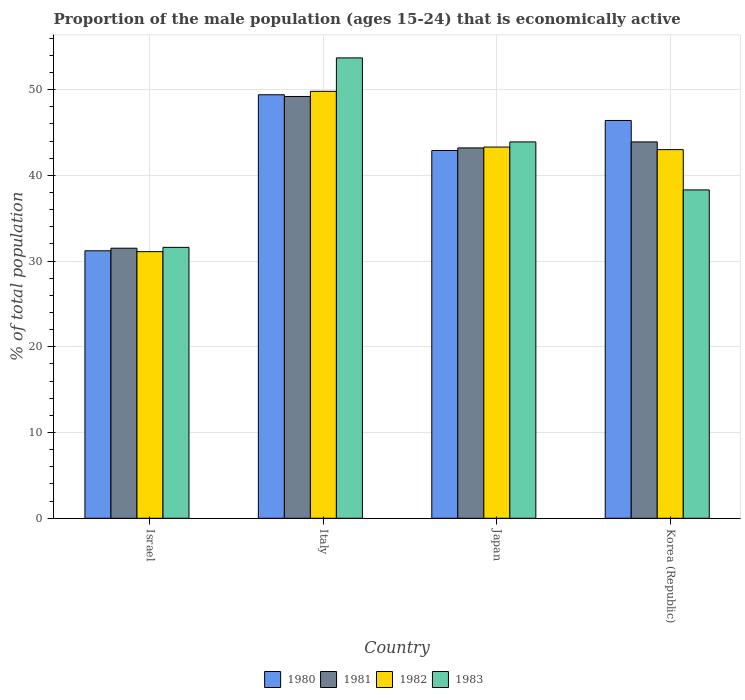How many different coloured bars are there?
Your response must be concise. 4. How many bars are there on the 1st tick from the left?
Your response must be concise. 4. What is the proportion of the male population that is economically active in 1980 in Korea (Republic)?
Make the answer very short. 46.4. Across all countries, what is the maximum proportion of the male population that is economically active in 1983?
Your response must be concise. 53.7. Across all countries, what is the minimum proportion of the male population that is economically active in 1983?
Offer a very short reply. 31.6. In which country was the proportion of the male population that is economically active in 1980 maximum?
Make the answer very short. Italy. What is the total proportion of the male population that is economically active in 1983 in the graph?
Offer a very short reply. 167.5. What is the difference between the proportion of the male population that is economically active in 1980 in Italy and that in Japan?
Provide a short and direct response. 6.5. What is the difference between the proportion of the male population that is economically active in 1981 in Japan and the proportion of the male population that is economically active in 1982 in Italy?
Provide a succinct answer. -6.6. What is the average proportion of the male population that is economically active in 1980 per country?
Your answer should be compact. 42.48. What is the difference between the proportion of the male population that is economically active of/in 1980 and proportion of the male population that is economically active of/in 1982 in Israel?
Make the answer very short. 0.1. What is the ratio of the proportion of the male population that is economically active in 1982 in Italy to that in Korea (Republic)?
Your response must be concise. 1.16. What is the difference between the highest and the second highest proportion of the male population that is economically active in 1980?
Keep it short and to the point. 6.5. What is the difference between the highest and the lowest proportion of the male population that is economically active in 1983?
Offer a very short reply. 22.1. In how many countries, is the proportion of the male population that is economically active in 1983 greater than the average proportion of the male population that is economically active in 1983 taken over all countries?
Offer a terse response. 2. Is it the case that in every country, the sum of the proportion of the male population that is economically active in 1980 and proportion of the male population that is economically active in 1982 is greater than the sum of proportion of the male population that is economically active in 1981 and proportion of the male population that is economically active in 1983?
Make the answer very short. No. Is it the case that in every country, the sum of the proportion of the male population that is economically active in 1980 and proportion of the male population that is economically active in 1982 is greater than the proportion of the male population that is economically active in 1983?
Ensure brevity in your answer.  Yes. How many countries are there in the graph?
Ensure brevity in your answer.  4. What is the difference between two consecutive major ticks on the Y-axis?
Your response must be concise. 10. Where does the legend appear in the graph?
Keep it short and to the point. Bottom center. How many legend labels are there?
Provide a succinct answer. 4. What is the title of the graph?
Provide a short and direct response. Proportion of the male population (ages 15-24) that is economically active. Does "2012" appear as one of the legend labels in the graph?
Your answer should be very brief. No. What is the label or title of the Y-axis?
Offer a terse response. % of total population. What is the % of total population of 1980 in Israel?
Make the answer very short. 31.2. What is the % of total population in 1981 in Israel?
Your response must be concise. 31.5. What is the % of total population in 1982 in Israel?
Offer a terse response. 31.1. What is the % of total population of 1983 in Israel?
Keep it short and to the point. 31.6. What is the % of total population of 1980 in Italy?
Your response must be concise. 49.4. What is the % of total population in 1981 in Italy?
Your answer should be compact. 49.2. What is the % of total population of 1982 in Italy?
Ensure brevity in your answer.  49.8. What is the % of total population of 1983 in Italy?
Give a very brief answer. 53.7. What is the % of total population in 1980 in Japan?
Your answer should be very brief. 42.9. What is the % of total population of 1981 in Japan?
Give a very brief answer. 43.2. What is the % of total population in 1982 in Japan?
Your response must be concise. 43.3. What is the % of total population in 1983 in Japan?
Offer a very short reply. 43.9. What is the % of total population in 1980 in Korea (Republic)?
Provide a succinct answer. 46.4. What is the % of total population in 1981 in Korea (Republic)?
Your response must be concise. 43.9. What is the % of total population of 1983 in Korea (Republic)?
Give a very brief answer. 38.3. Across all countries, what is the maximum % of total population in 1980?
Ensure brevity in your answer.  49.4. Across all countries, what is the maximum % of total population in 1981?
Your response must be concise. 49.2. Across all countries, what is the maximum % of total population in 1982?
Your response must be concise. 49.8. Across all countries, what is the maximum % of total population in 1983?
Offer a very short reply. 53.7. Across all countries, what is the minimum % of total population of 1980?
Your answer should be very brief. 31.2. Across all countries, what is the minimum % of total population of 1981?
Offer a terse response. 31.5. Across all countries, what is the minimum % of total population of 1982?
Offer a terse response. 31.1. Across all countries, what is the minimum % of total population of 1983?
Your answer should be compact. 31.6. What is the total % of total population of 1980 in the graph?
Provide a succinct answer. 169.9. What is the total % of total population of 1981 in the graph?
Provide a succinct answer. 167.8. What is the total % of total population in 1982 in the graph?
Your response must be concise. 167.2. What is the total % of total population in 1983 in the graph?
Offer a very short reply. 167.5. What is the difference between the % of total population of 1980 in Israel and that in Italy?
Ensure brevity in your answer.  -18.2. What is the difference between the % of total population in 1981 in Israel and that in Italy?
Your answer should be compact. -17.7. What is the difference between the % of total population in 1982 in Israel and that in Italy?
Offer a terse response. -18.7. What is the difference between the % of total population of 1983 in Israel and that in Italy?
Offer a terse response. -22.1. What is the difference between the % of total population in 1982 in Israel and that in Japan?
Offer a very short reply. -12.2. What is the difference between the % of total population in 1983 in Israel and that in Japan?
Keep it short and to the point. -12.3. What is the difference between the % of total population of 1980 in Israel and that in Korea (Republic)?
Offer a terse response. -15.2. What is the difference between the % of total population of 1981 in Israel and that in Korea (Republic)?
Your answer should be compact. -12.4. What is the difference between the % of total population in 1983 in Israel and that in Korea (Republic)?
Offer a very short reply. -6.7. What is the difference between the % of total population in 1981 in Italy and that in Japan?
Provide a succinct answer. 6. What is the difference between the % of total population of 1982 in Italy and that in Japan?
Give a very brief answer. 6.5. What is the difference between the % of total population of 1982 in Italy and that in Korea (Republic)?
Provide a short and direct response. 6.8. What is the difference between the % of total population of 1980 in Japan and that in Korea (Republic)?
Offer a very short reply. -3.5. What is the difference between the % of total population in 1981 in Japan and that in Korea (Republic)?
Provide a succinct answer. -0.7. What is the difference between the % of total population of 1980 in Israel and the % of total population of 1981 in Italy?
Ensure brevity in your answer.  -18. What is the difference between the % of total population in 1980 in Israel and the % of total population in 1982 in Italy?
Make the answer very short. -18.6. What is the difference between the % of total population in 1980 in Israel and the % of total population in 1983 in Italy?
Your response must be concise. -22.5. What is the difference between the % of total population in 1981 in Israel and the % of total population in 1982 in Italy?
Ensure brevity in your answer.  -18.3. What is the difference between the % of total population of 1981 in Israel and the % of total population of 1983 in Italy?
Make the answer very short. -22.2. What is the difference between the % of total population of 1982 in Israel and the % of total population of 1983 in Italy?
Ensure brevity in your answer.  -22.6. What is the difference between the % of total population of 1980 in Israel and the % of total population of 1982 in Japan?
Provide a short and direct response. -12.1. What is the difference between the % of total population in 1980 in Israel and the % of total population in 1983 in Japan?
Offer a very short reply. -12.7. What is the difference between the % of total population in 1981 in Israel and the % of total population in 1982 in Japan?
Offer a very short reply. -11.8. What is the difference between the % of total population in 1980 in Israel and the % of total population in 1982 in Korea (Republic)?
Keep it short and to the point. -11.8. What is the difference between the % of total population of 1980 in Israel and the % of total population of 1983 in Korea (Republic)?
Provide a succinct answer. -7.1. What is the difference between the % of total population of 1982 in Israel and the % of total population of 1983 in Korea (Republic)?
Provide a short and direct response. -7.2. What is the difference between the % of total population of 1980 in Italy and the % of total population of 1983 in Japan?
Your answer should be compact. 5.5. What is the difference between the % of total population of 1981 in Italy and the % of total population of 1982 in Japan?
Keep it short and to the point. 5.9. What is the difference between the % of total population in 1981 in Italy and the % of total population in 1982 in Korea (Republic)?
Ensure brevity in your answer.  6.2. What is the difference between the % of total population in 1980 in Japan and the % of total population in 1981 in Korea (Republic)?
Offer a terse response. -1. What is the difference between the % of total population in 1980 in Japan and the % of total population in 1982 in Korea (Republic)?
Provide a succinct answer. -0.1. What is the difference between the % of total population of 1980 in Japan and the % of total population of 1983 in Korea (Republic)?
Your answer should be compact. 4.6. What is the difference between the % of total population of 1981 in Japan and the % of total population of 1982 in Korea (Republic)?
Keep it short and to the point. 0.2. What is the difference between the % of total population of 1982 in Japan and the % of total population of 1983 in Korea (Republic)?
Your answer should be compact. 5. What is the average % of total population of 1980 per country?
Make the answer very short. 42.48. What is the average % of total population of 1981 per country?
Provide a short and direct response. 41.95. What is the average % of total population in 1982 per country?
Ensure brevity in your answer.  41.8. What is the average % of total population in 1983 per country?
Keep it short and to the point. 41.88. What is the difference between the % of total population in 1980 and % of total population in 1983 in Israel?
Your answer should be compact. -0.4. What is the difference between the % of total population of 1981 and % of total population of 1983 in Israel?
Make the answer very short. -0.1. What is the difference between the % of total population of 1980 and % of total population of 1981 in Italy?
Keep it short and to the point. 0.2. What is the difference between the % of total population of 1981 and % of total population of 1982 in Italy?
Your answer should be very brief. -0.6. What is the difference between the % of total population in 1981 and % of total population in 1983 in Italy?
Offer a very short reply. -4.5. What is the difference between the % of total population of 1980 and % of total population of 1981 in Japan?
Provide a succinct answer. -0.3. What is the difference between the % of total population of 1980 and % of total population of 1982 in Japan?
Your response must be concise. -0.4. What is the difference between the % of total population of 1980 and % of total population of 1983 in Japan?
Offer a very short reply. -1. What is the difference between the % of total population of 1981 and % of total population of 1983 in Japan?
Give a very brief answer. -0.7. What is the difference between the % of total population in 1982 and % of total population in 1983 in Japan?
Provide a short and direct response. -0.6. What is the difference between the % of total population of 1980 and % of total population of 1983 in Korea (Republic)?
Keep it short and to the point. 8.1. What is the difference between the % of total population in 1981 and % of total population in 1982 in Korea (Republic)?
Offer a terse response. 0.9. What is the ratio of the % of total population in 1980 in Israel to that in Italy?
Offer a very short reply. 0.63. What is the ratio of the % of total population of 1981 in Israel to that in Italy?
Offer a very short reply. 0.64. What is the ratio of the % of total population of 1982 in Israel to that in Italy?
Your answer should be very brief. 0.62. What is the ratio of the % of total population of 1983 in Israel to that in Italy?
Keep it short and to the point. 0.59. What is the ratio of the % of total population in 1980 in Israel to that in Japan?
Keep it short and to the point. 0.73. What is the ratio of the % of total population of 1981 in Israel to that in Japan?
Offer a very short reply. 0.73. What is the ratio of the % of total population in 1982 in Israel to that in Japan?
Make the answer very short. 0.72. What is the ratio of the % of total population in 1983 in Israel to that in Japan?
Make the answer very short. 0.72. What is the ratio of the % of total population of 1980 in Israel to that in Korea (Republic)?
Offer a very short reply. 0.67. What is the ratio of the % of total population in 1981 in Israel to that in Korea (Republic)?
Offer a terse response. 0.72. What is the ratio of the % of total population of 1982 in Israel to that in Korea (Republic)?
Your answer should be compact. 0.72. What is the ratio of the % of total population in 1983 in Israel to that in Korea (Republic)?
Keep it short and to the point. 0.83. What is the ratio of the % of total population of 1980 in Italy to that in Japan?
Offer a very short reply. 1.15. What is the ratio of the % of total population of 1981 in Italy to that in Japan?
Offer a very short reply. 1.14. What is the ratio of the % of total population in 1982 in Italy to that in Japan?
Keep it short and to the point. 1.15. What is the ratio of the % of total population in 1983 in Italy to that in Japan?
Provide a succinct answer. 1.22. What is the ratio of the % of total population of 1980 in Italy to that in Korea (Republic)?
Provide a short and direct response. 1.06. What is the ratio of the % of total population in 1981 in Italy to that in Korea (Republic)?
Your answer should be compact. 1.12. What is the ratio of the % of total population of 1982 in Italy to that in Korea (Republic)?
Give a very brief answer. 1.16. What is the ratio of the % of total population of 1983 in Italy to that in Korea (Republic)?
Make the answer very short. 1.4. What is the ratio of the % of total population in 1980 in Japan to that in Korea (Republic)?
Your answer should be compact. 0.92. What is the ratio of the % of total population in 1981 in Japan to that in Korea (Republic)?
Offer a terse response. 0.98. What is the ratio of the % of total population in 1983 in Japan to that in Korea (Republic)?
Make the answer very short. 1.15. What is the difference between the highest and the second highest % of total population of 1981?
Provide a short and direct response. 5.3. What is the difference between the highest and the second highest % of total population in 1982?
Give a very brief answer. 6.5. What is the difference between the highest and the lowest % of total population of 1981?
Provide a succinct answer. 17.7. What is the difference between the highest and the lowest % of total population in 1982?
Ensure brevity in your answer.  18.7. What is the difference between the highest and the lowest % of total population of 1983?
Offer a very short reply. 22.1. 